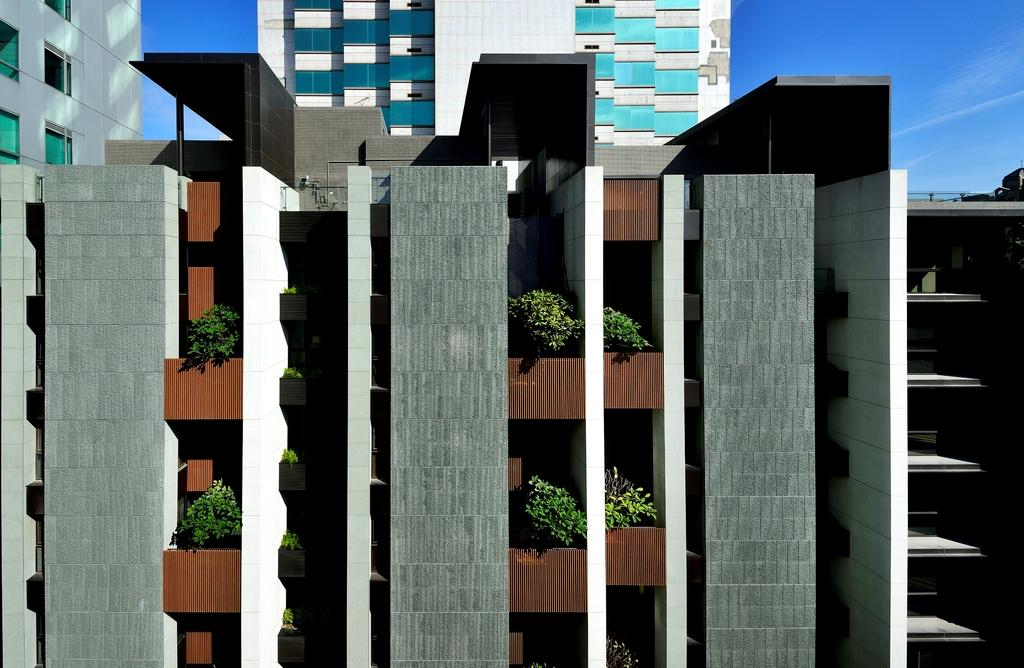What type of structure is visible in the image? There is a building in the image. What can be seen on the balcony of the building? There are plants in the balcony of the building. What other tall structure is present in the image? There is a tall tower in the image. How many windows are visible on the tall tower? The tall tower has plenty of windows. What type of liquid can be seen flowing from the windows of the tall tower in the image? There is no liquid flowing from the windows of the tall tower in the image. 